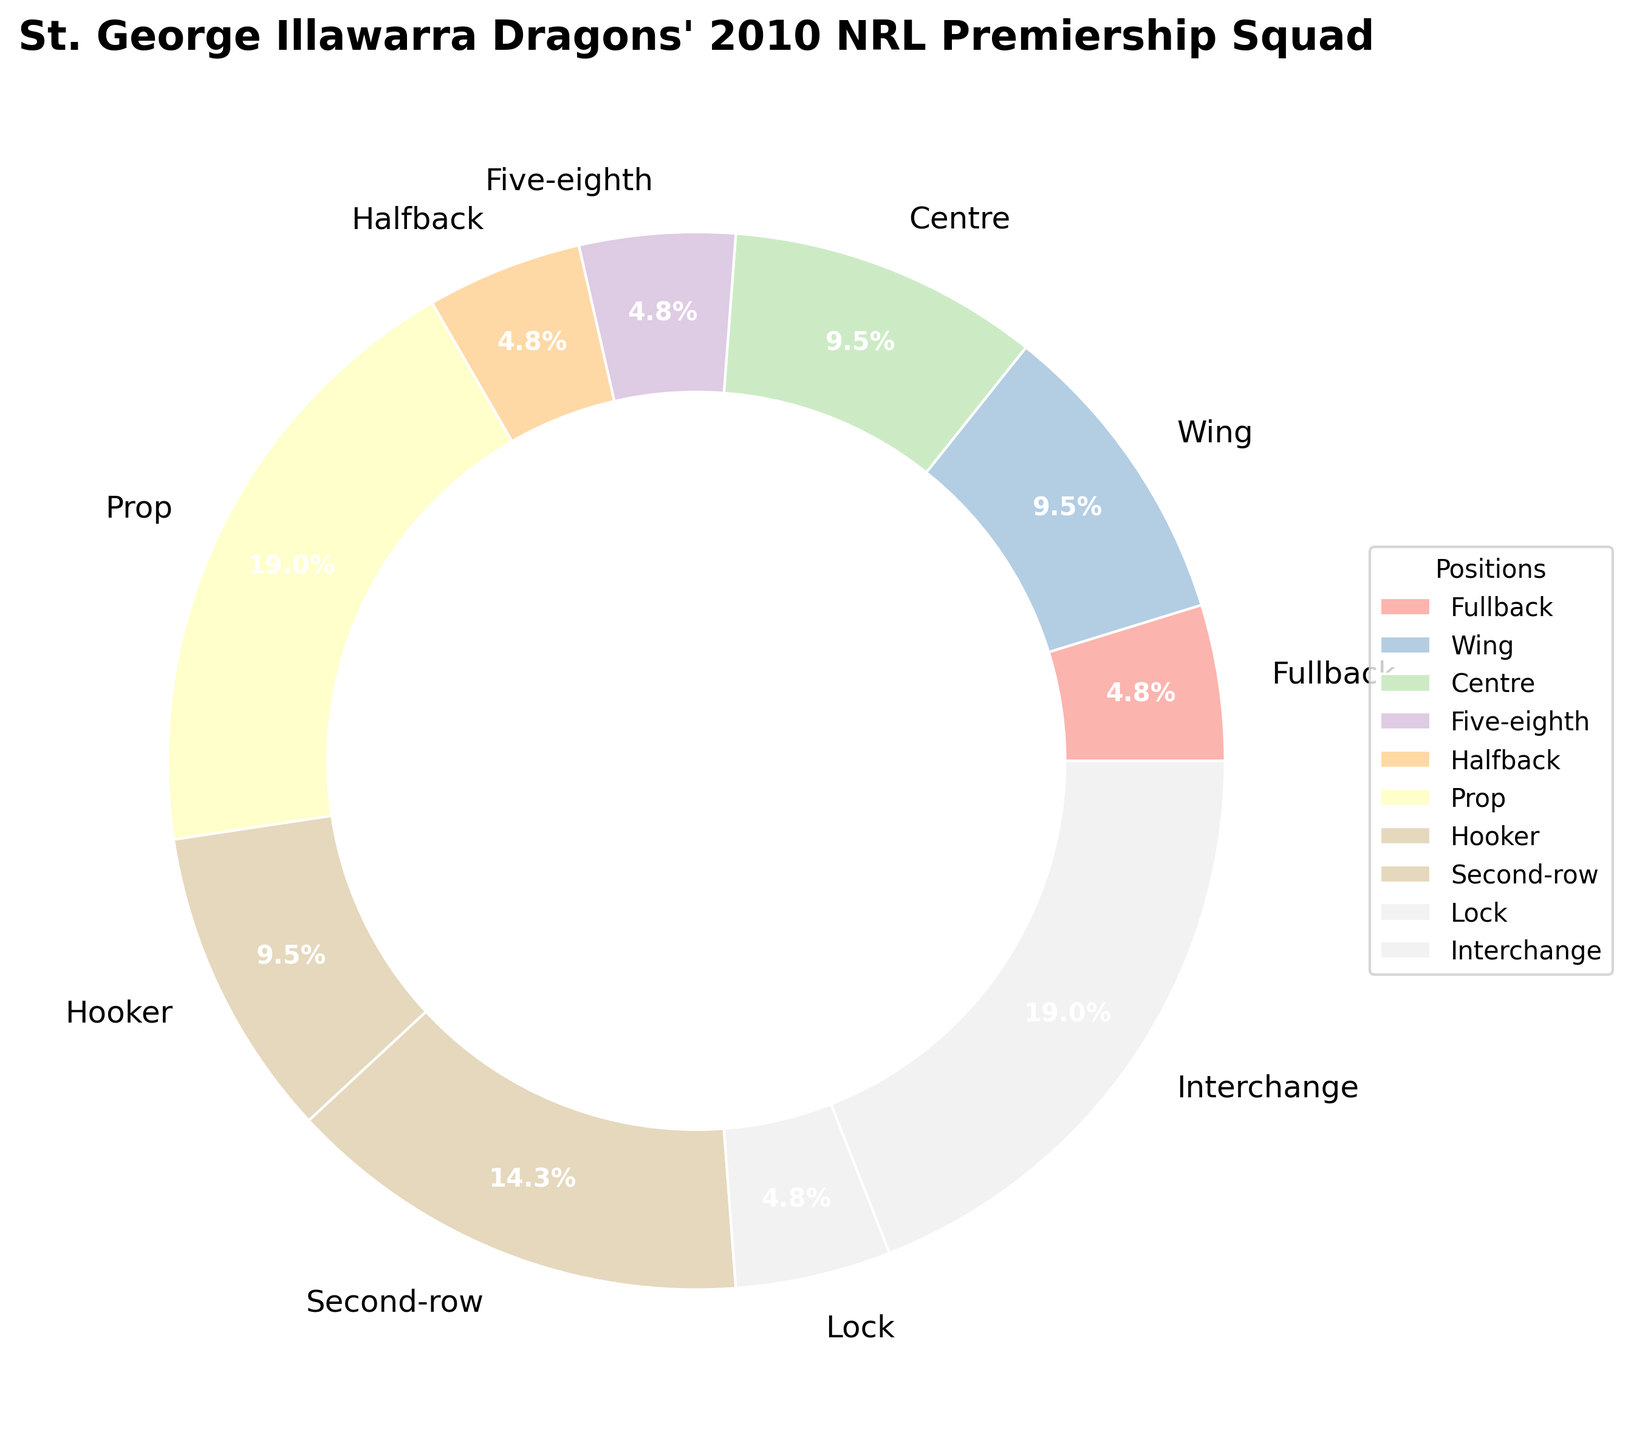what percentage of the squad were wingers? Look at the pie chart segment labeled "Wing" to find the percentage.
Answer: 11.1% How many positions had only one player? Count the segments where the number of players equals one.
Answer: 4 Which position had the highest number of players? Identify the largest segment in the pie chart and check its label.
Answer: Prop Are there more players in the "Interchange" or the "Second-row" positions? Compare the sizes of segments labeled "Interchange" and "Second-row" to see which is larger.
Answer: Interchange What is the combined percentage of players in the "Hooker" and "Second-row" positions? Add the percentages of the "Hooker" and "Second-row" segments. Hooker is 11.1%, and Second-row is 16.7%, so 11.1% + 16.7% = 27.8%.
Answer: 27.8% What is the average number of players per position? Sum the total number of players and divide by the number of positions. There are 21 players across 10 positions, so 21/10 = 2.1.
Answer: 2.1 Which is the smallest segment and what percentage does it represent? Identify the smallest segment in the pie chart and check its label and percentage.
Answer: Fullback 5.6% How does the number of players in the "Lock" position compare to the "Hooker" position? Compare the sizes of segments for "Lock" and "Hooker" positions.
Answer: Smaller What is the difference in the number of players between the "Prop" and "Second-row" positions? Subtract the number of players in "Second-row" from those in "Prop." 4 (Prop) - 3 (Second-row) = 1.
Answer: 1 